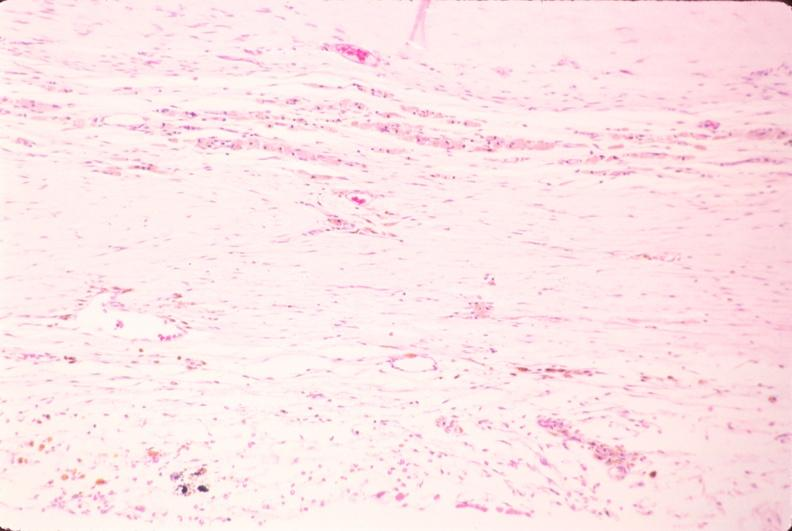what does this image show?
Answer the question using a single word or phrase. Brain 